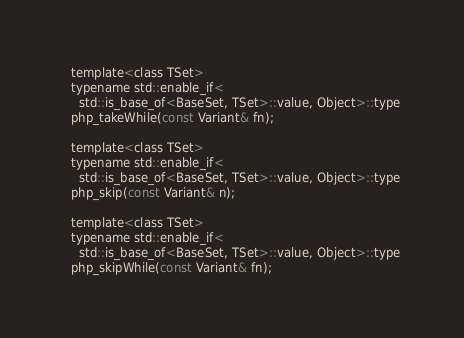<code> <loc_0><loc_0><loc_500><loc_500><_C_>
  template<class TSet>
  typename std::enable_if<
    std::is_base_of<BaseSet, TSet>::value, Object>::type
  php_takeWhile(const Variant& fn);

  template<class TSet>
  typename std::enable_if<
    std::is_base_of<BaseSet, TSet>::value, Object>::type
  php_skip(const Variant& n);

  template<class TSet>
  typename std::enable_if<
    std::is_base_of<BaseSet, TSet>::value, Object>::type
  php_skipWhile(const Variant& fn);
</code> 